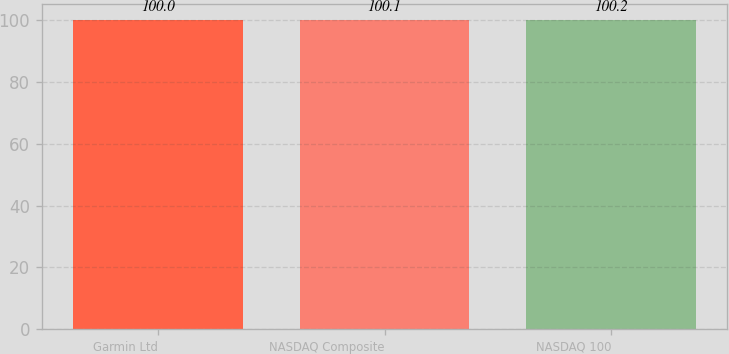Convert chart. <chart><loc_0><loc_0><loc_500><loc_500><bar_chart><fcel>Garmin Ltd<fcel>NASDAQ Composite<fcel>NASDAQ 100<nl><fcel>100<fcel>100.1<fcel>100.2<nl></chart> 